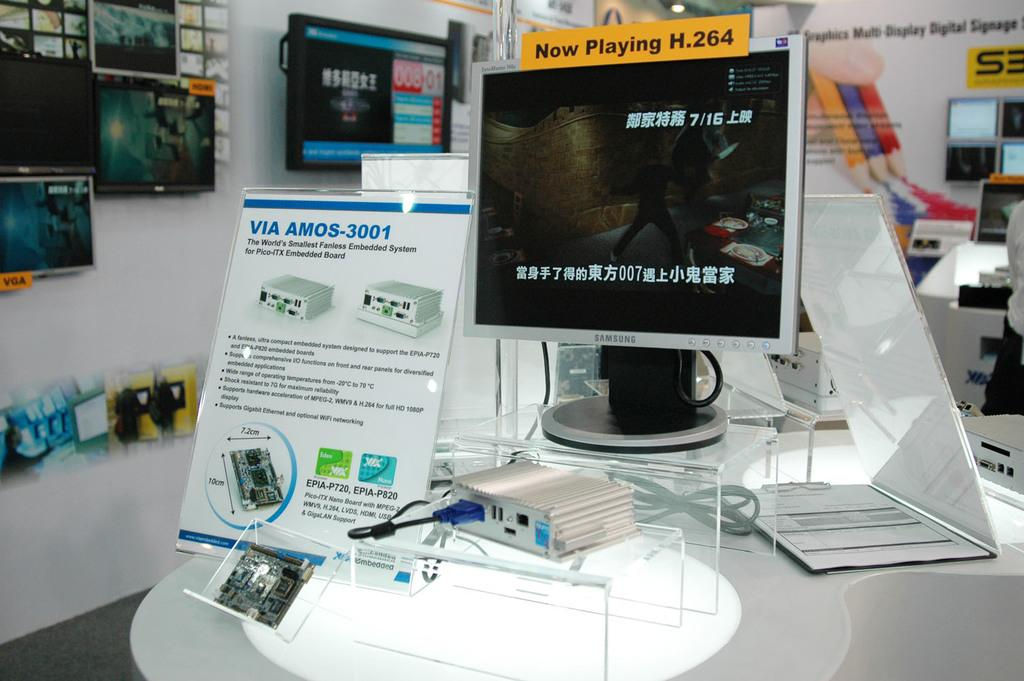<image>
Provide a brief description of the given image. The sign says now playing H 264 on the screen 